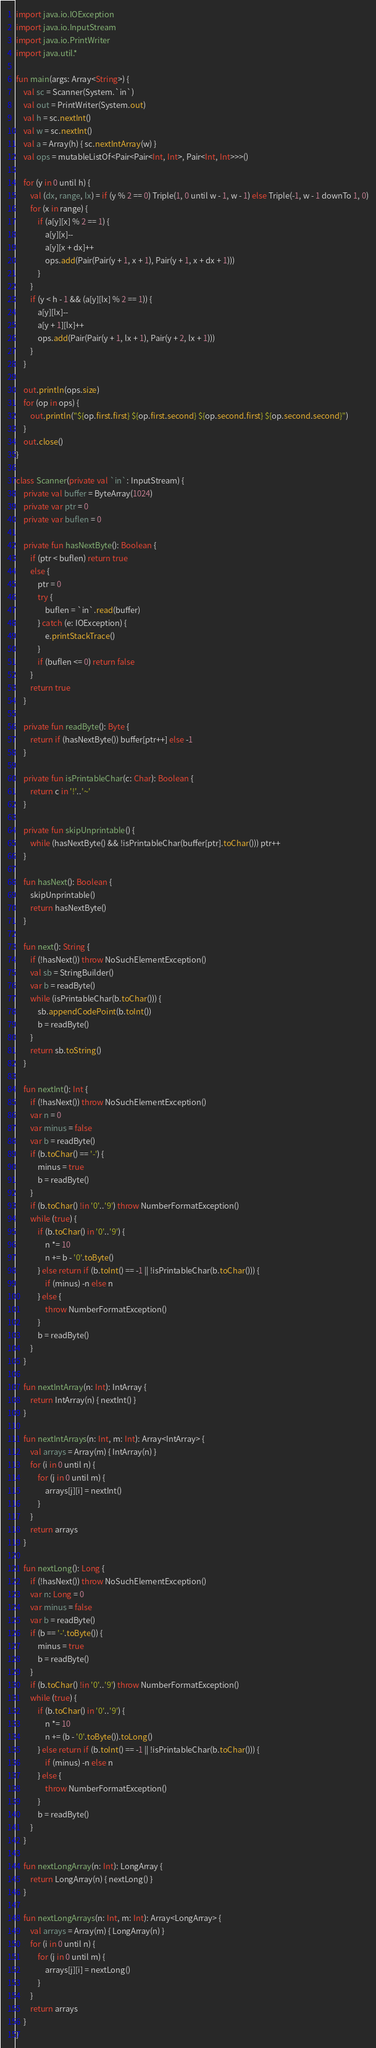Convert code to text. <code><loc_0><loc_0><loc_500><loc_500><_Kotlin_>import java.io.IOException
import java.io.InputStream
import java.io.PrintWriter
import java.util.*

fun main(args: Array<String>) {
    val sc = Scanner(System.`in`)
    val out = PrintWriter(System.out)
    val h = sc.nextInt()
    val w = sc.nextInt()
    val a = Array(h) { sc.nextIntArray(w) }
    val ops = mutableListOf<Pair<Pair<Int, Int>, Pair<Int, Int>>>()

    for (y in 0 until h) {
        val (dx, range, lx) = if (y % 2 == 0) Triple(1, 0 until w - 1, w - 1) else Triple(-1, w - 1 downTo 1, 0)
        for (x in range) {
            if (a[y][x] % 2 == 1) {
                a[y][x]--
                a[y][x + dx]++
                ops.add(Pair(Pair(y + 1, x + 1), Pair(y + 1, x + dx + 1)))
            }
        }
        if (y < h - 1 && (a[y][lx] % 2 == 1)) {
            a[y][lx]--
            a[y + 1][lx]++
            ops.add(Pair(Pair(y + 1, lx + 1), Pair(y + 2, lx + 1)))
        }
    }

    out.println(ops.size)
    for (op in ops) {
        out.println("${op.first.first} ${op.first.second} ${op.second.first} ${op.second.second}")
    }
    out.close()
}

class Scanner(private val `in`: InputStream) {
    private val buffer = ByteArray(1024)
    private var ptr = 0
    private var buflen = 0

    private fun hasNextByte(): Boolean {
        if (ptr < buflen) return true
        else {
            ptr = 0
            try {
                buflen = `in`.read(buffer)
            } catch (e: IOException) {
                e.printStackTrace()
            }
            if (buflen <= 0) return false
        }
        return true
    }

    private fun readByte(): Byte {
        return if (hasNextByte()) buffer[ptr++] else -1
    }

    private fun isPrintableChar(c: Char): Boolean {
        return c in '!'..'~'
    }

    private fun skipUnprintable() {
        while (hasNextByte() && !isPrintableChar(buffer[ptr].toChar())) ptr++
    }

    fun hasNext(): Boolean {
        skipUnprintable()
        return hasNextByte()
    }

    fun next(): String {
        if (!hasNext()) throw NoSuchElementException()
        val sb = StringBuilder()
        var b = readByte()
        while (isPrintableChar(b.toChar())) {
            sb.appendCodePoint(b.toInt())
            b = readByte()
        }
        return sb.toString()
    }

    fun nextInt(): Int {
        if (!hasNext()) throw NoSuchElementException()
        var n = 0
        var minus = false
        var b = readByte()
        if (b.toChar() == '-') {
            minus = true
            b = readByte()
        }
        if (b.toChar() !in '0'..'9') throw NumberFormatException()
        while (true) {
            if (b.toChar() in '0'..'9') {
                n *= 10
                n += b - '0'.toByte()
            } else return if (b.toInt() == -1 || !isPrintableChar(b.toChar())) {
                if (minus) -n else n
            } else {
                throw NumberFormatException()
            }
            b = readByte()
        }
    }

    fun nextIntArray(n: Int): IntArray {
        return IntArray(n) { nextInt() }
    }

    fun nextIntArrays(n: Int, m: Int): Array<IntArray> {
        val arrays = Array(m) { IntArray(n) }
        for (i in 0 until n) {
            for (j in 0 until m) {
                arrays[j][i] = nextInt()
            }
        }
        return arrays
    }

    fun nextLong(): Long {
        if (!hasNext()) throw NoSuchElementException()
        var n: Long = 0
        var minus = false
        var b = readByte()
        if (b == '-'.toByte()) {
            minus = true
            b = readByte()
        }
        if (b.toChar() !in '0'..'9') throw NumberFormatException()
        while (true) {
            if (b.toChar() in '0'..'9') {
                n *= 10
                n += (b - '0'.toByte()).toLong()
            } else return if (b.toInt() == -1 || !isPrintableChar(b.toChar())) {
                if (minus) -n else n
            } else {
                throw NumberFormatException()
            }
            b = readByte()
        }
    }

    fun nextLongArray(n: Int): LongArray {
        return LongArray(n) { nextLong() }
    }

    fun nextLongArrays(n: Int, m: Int): Array<LongArray> {
        val arrays = Array(m) { LongArray(n) }
        for (i in 0 until n) {
            for (j in 0 until m) {
                arrays[j][i] = nextLong()
            }
        }
        return arrays
    }
}
</code> 